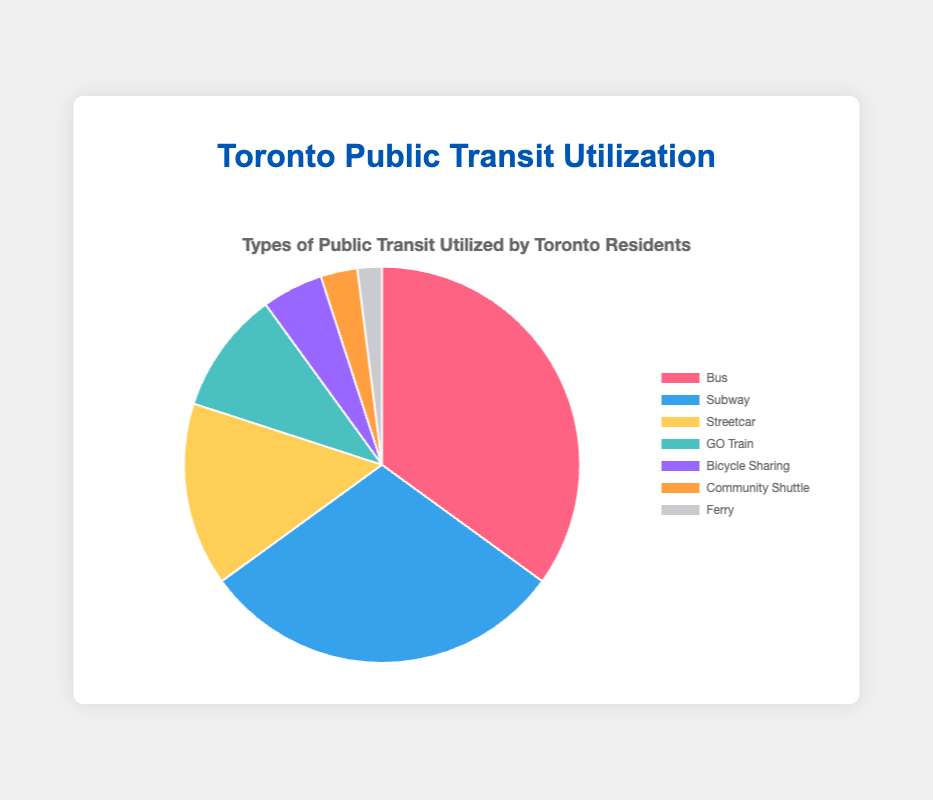What percentage of Toronto residents use the bus for public transit? By observing the pie chart's segments, the segment labeled "Bus" represents 35% of the whole chart.
Answer: 35% What is the most utilized form of public transit in Toronto? The largest segment in the pie chart, which represents the "Bus," indicates it is the most utilized transit option with 35%.
Answer: Bus Which is used more, the GO Train or the Streetcar, and by how much? Comparing the segments, the Streetcar is 15% and the GO Train is 10%. The Streetcar is used 5% more than the GO Train.
Answer: Streetcar by 5% What's the combined percentage of residents using either Subway or Streetcar? The Subway accounts for 30% and the Streetcar for 15%. Adding these gives 30% + 15% = 45%.
Answer: 45% Is Bicycle Sharing more popular than Community Shuttle? The chart shows Bicycle Sharing at 5% and Community Shuttle at 3%. Thus, Bicycle Sharing is more popular.
Answer: Yes Compare the least utilized mode of transit to the most utilized mode. The least utilized mode is the Ferry at 2%, and the most utilized mode is the Bus at 35%.
Answer: 2% vs 35% What modes of public transit are used by less than 10% of residents? The segments for Bicycle Sharing (5%), Community Shuttle (3%), and Ferry (2%) are all less than 10%.
Answer: Bicycle Sharing, Community Shuttle, Ferry Which modes have between 10% and 20% utilization? Only the Streetcar falls into this category with 15% utilization.
Answer: Streetcar How many modes of public transit have a utilization rate above 25%? The Bus (35%) and Subway (30%) segments are each above 25%, making up 2 modes.
Answer: 2 What is the difference in utilization between the Subway and the Ferry? The Subway is utilized by 30% of residents while the Ferry is utilized by 2%, the difference being 30% - 2% = 28%.
Answer: 28% 